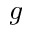Convert formula to latex. <formula><loc_0><loc_0><loc_500><loc_500>g</formula> 